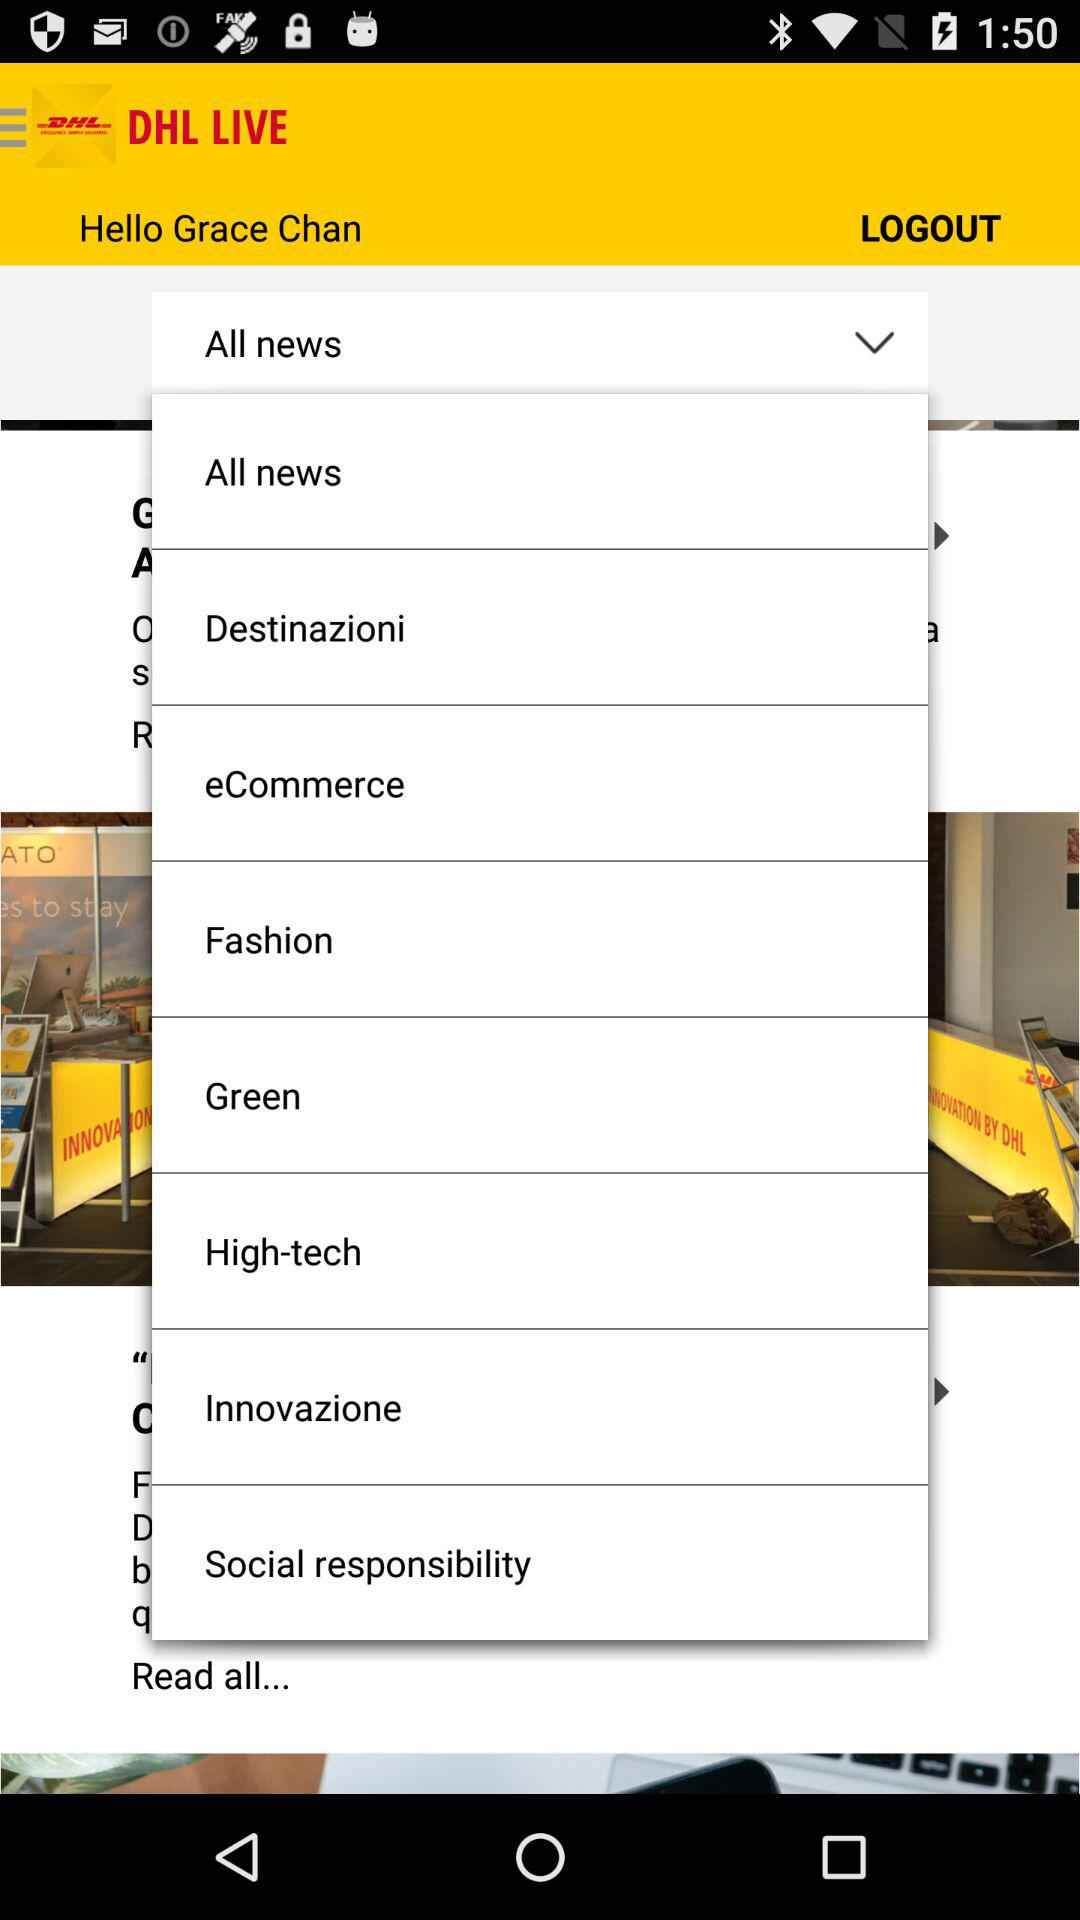What is the application name? The application name is "DHL LIVE". 